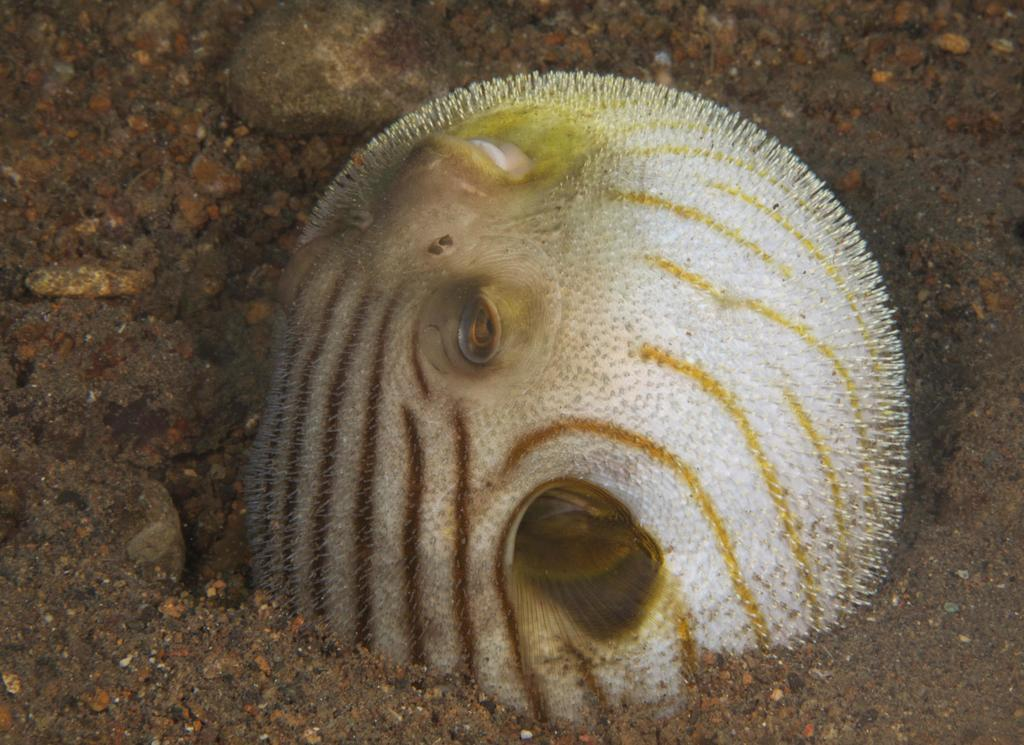What type of animals can be seen in the image? There are fish in the image. What can be found on the ground in the image? There are stones on the ground in the image. How many birds are in the flock that is visible in the image? There is no flock of birds present in the image; it features fish and stones. 